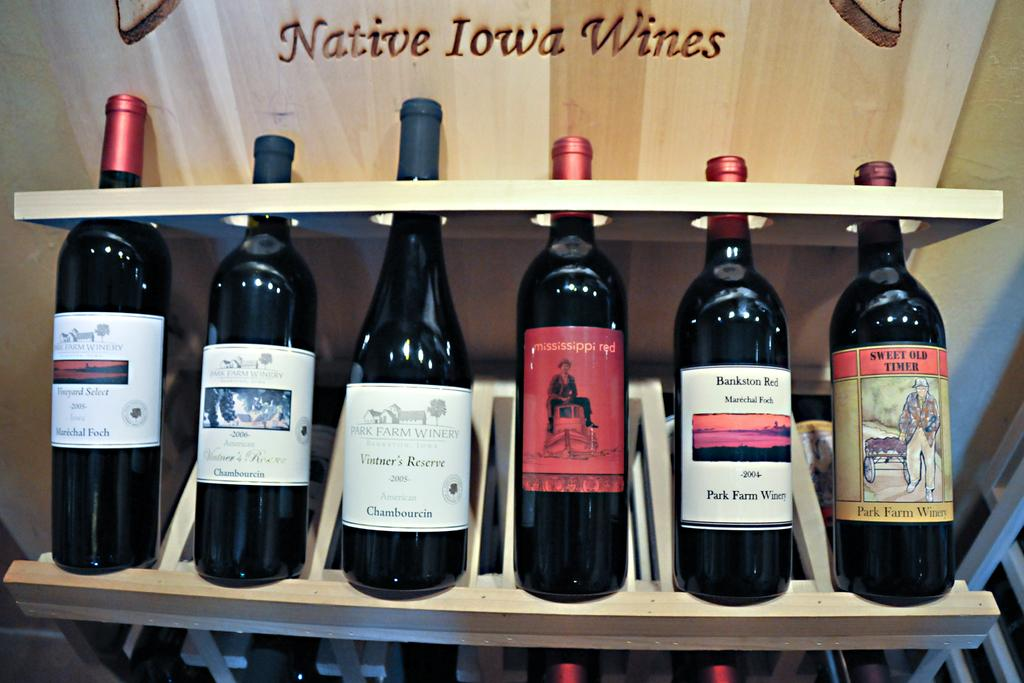Provide a one-sentence caption for the provided image. A number of red native Iowa wines on display. 